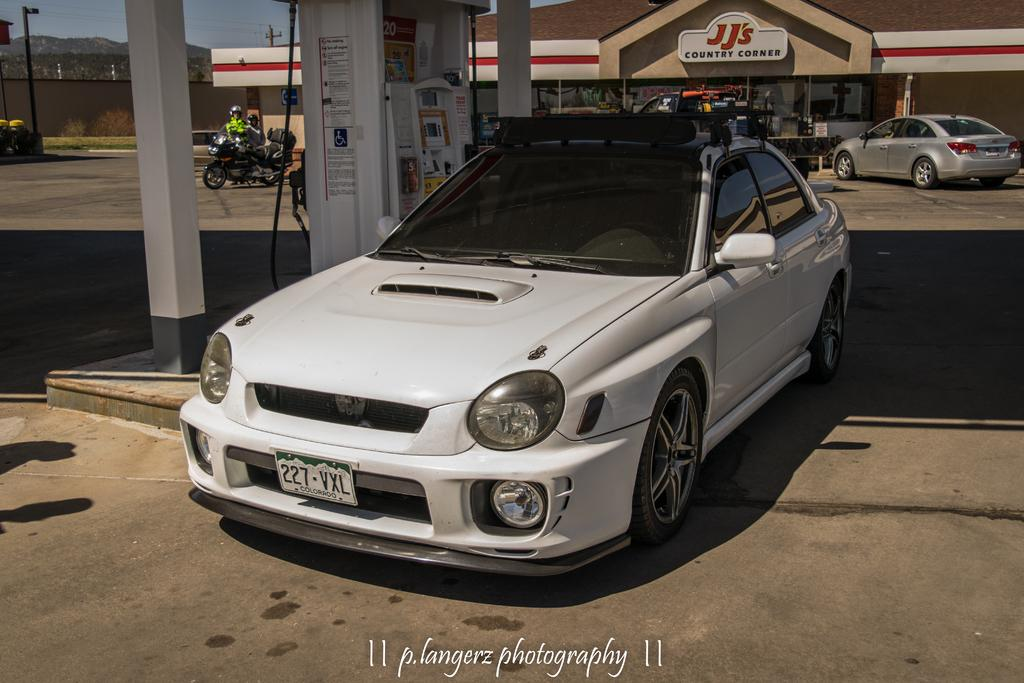What types of vehicles are in the image? There are vehicles in the image, but the specific types are not mentioned. What is the purpose of the fuel dispenser in the image? The fuel dispenser is likely used for refueling vehicles. What can be seen in the background of the image? In the background of the image, there are stalls, light poles, and trees. What color is the sky in the image? The sky is blue in the image. How many beds can be seen in the image? There are no beds present in the image. What level of the building is the image taken from? The image does not provide information about the level of the building. 